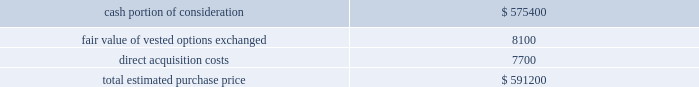Hologic , inc .
Notes to consolidated financial statements ( continued ) ( in thousands , except per share data ) 3 .
Business combinations fiscal 2008 acquisitions : acquisition of third wave technologies , inc .
On july 24 , 2008 the company completed its acquisition of third wave technologies , inc .
( 201cthird wave 201d ) pursuant to a definitive agreement dated june 8 , 2008 .
The company has concluded that the acquisition of third wave does not represent a material business combination and therefore no pro forma financial information has been provided herein .
Subsequent to the acquisition date , the company 2019s results of operations include the results of third wave , which has been reported as a component of the company 2019s diagnostics reporting segment .
Third wave , located in madison , wisconsin , develops and markets molecular diagnostic reagents for a wide variety of dna and rna analysis applications based on its proprietary invader chemistry .
Third wave 2019s current clinical diagnostic offerings consist of products for conditions such as cystic fibrosis , hepatitis c , cardiovascular risk and other diseases .
Third wave recently submitted to the u.s .
Food and drug administration ( 201cfda 201d ) pre-market approval ( 201cpma 201d ) applications for two human papillomavirus ( 201chpv 201d ) tests .
The company paid $ 11.25 per share of third wave , for an aggregate purchase price of approximately $ 591200 ( subject to adjustment ) consisting of approximately $ 575400 in cash in exchange for stock and warrants ; approximately 668 of fully vested stock options granted to third wave employees in exchange for their vested third wave stock options , with an estimated fair value of approximately $ 8100 ; and approximately $ 7700 for acquisition related fees and expenses .
There are no potential contingent consideration arrangements payable to the former shareholders in connection with this transaction .
Additionally , the company granted approximately 315 unvested stock options in exchange for unvested third wave stock options , with an estimated fair value of approximately $ 5100 , which will be recognized as compensation expense over the vesting period .
The company determined the fair value of the options issued in connection with the acquisition in accordance with eitf issue no .
99-12 , determination of the measurement date for the market price of acquirer securities issued in a purchase business combination 201d ) .
The company determined the measurement date to be july 24 , 2008 , the date the transaction was completed , as the number of shares to be issued according to the exchange ratio was not fixed until this date .
The company valued the securities based on the average market price for two days before the measurement date and the measurement date itself .
The weighted average stock price was determined to be approximately $ 23.54 .
The preliminary purchase price is as follows: .

What portion of the estimated purchase price is paid in cash? 
Computations: (575400 / 591200)
Answer: 0.97327. 